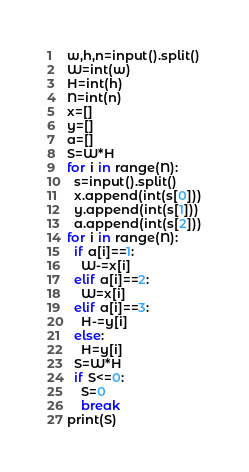Convert code to text. <code><loc_0><loc_0><loc_500><loc_500><_Python_>w,h,n=input().split()
W=int(w)
H=int(h)
N=int(n)
x=[]
y=[]
a=[]
S=W*H
for i in range(N):
  s=input().split()
  x.append(int(s[0]))
  y.append(int(s[1]))
  a.append(int(s[2]))
for i in range(N):
  if a[i]==1:
    W-=x[i]
  elif a[i]==2:
    W=x[i]
  elif a[i]==3:
    H-=y[i]
  else:
    H=y[i]
  S=W*H
  if S<=0:
    S=0
    break
print(S)</code> 